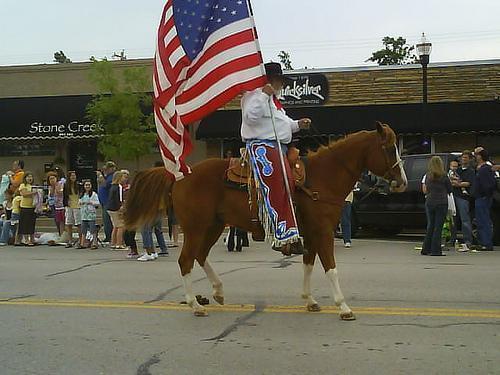What are the white marks on the horse's legs called?
Choose the correct response, then elucidate: 'Answer: answer
Rationale: rationale.'
Options: Boots, shoes, leggings, socks. Answer: socks.
Rationale: The horse has white feet. 